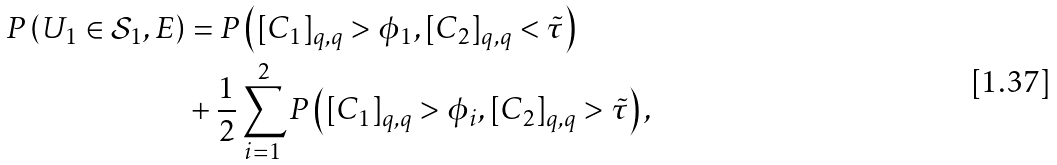<formula> <loc_0><loc_0><loc_500><loc_500>P \left ( U _ { 1 } \in \mathcal { S } _ { 1 } , E \right ) & = P \left ( [ C _ { 1 } ] _ { q , q } > \phi _ { 1 } , [ C _ { 2 } ] _ { q , q } < \tilde { \tau } \right ) \\ & + \frac { 1 } { 2 } \sum ^ { 2 } _ { i = 1 } P \left ( [ C _ { 1 } ] _ { q , q } > \phi _ { i } , [ C _ { 2 } ] _ { q , q } > \tilde { \tau } \right ) ,</formula> 